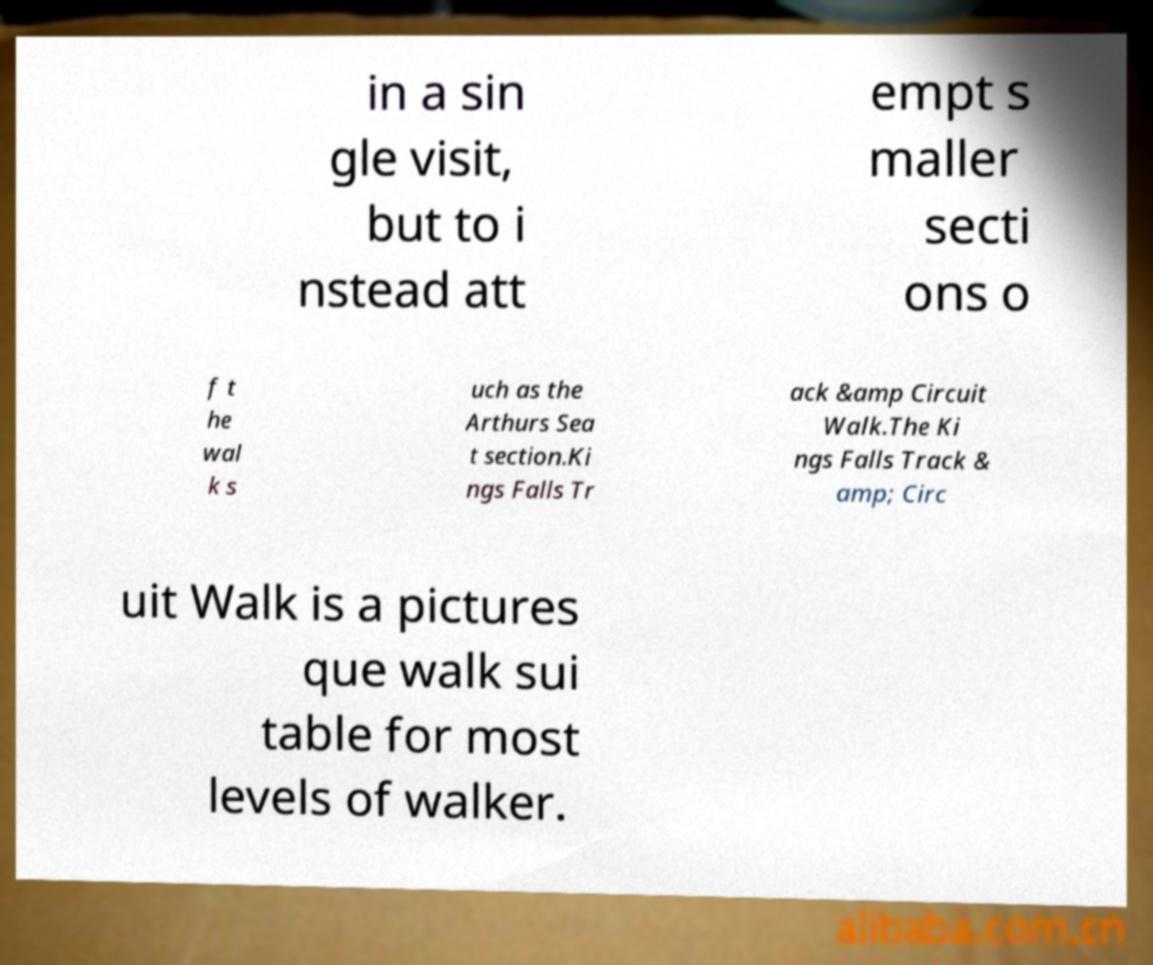Can you read and provide the text displayed in the image?This photo seems to have some interesting text. Can you extract and type it out for me? in a sin gle visit, but to i nstead att empt s maller secti ons o f t he wal k s uch as the Arthurs Sea t section.Ki ngs Falls Tr ack &amp Circuit Walk.The Ki ngs Falls Track & amp; Circ uit Walk is a pictures que walk sui table for most levels of walker. 